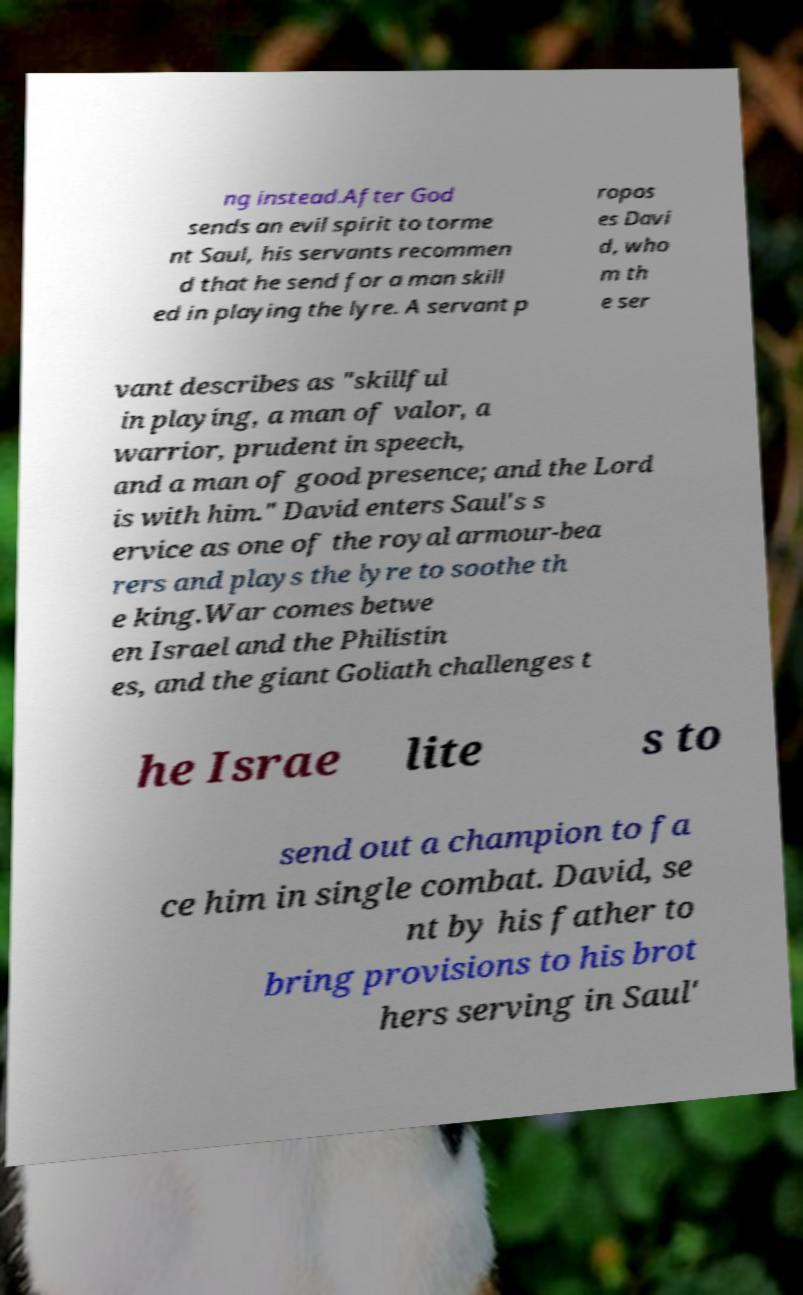Could you assist in decoding the text presented in this image and type it out clearly? ng instead.After God sends an evil spirit to torme nt Saul, his servants recommen d that he send for a man skill ed in playing the lyre. A servant p ropos es Davi d, who m th e ser vant describes as "skillful in playing, a man of valor, a warrior, prudent in speech, and a man of good presence; and the Lord is with him." David enters Saul's s ervice as one of the royal armour-bea rers and plays the lyre to soothe th e king.War comes betwe en Israel and the Philistin es, and the giant Goliath challenges t he Israe lite s to send out a champion to fa ce him in single combat. David, se nt by his father to bring provisions to his brot hers serving in Saul' 